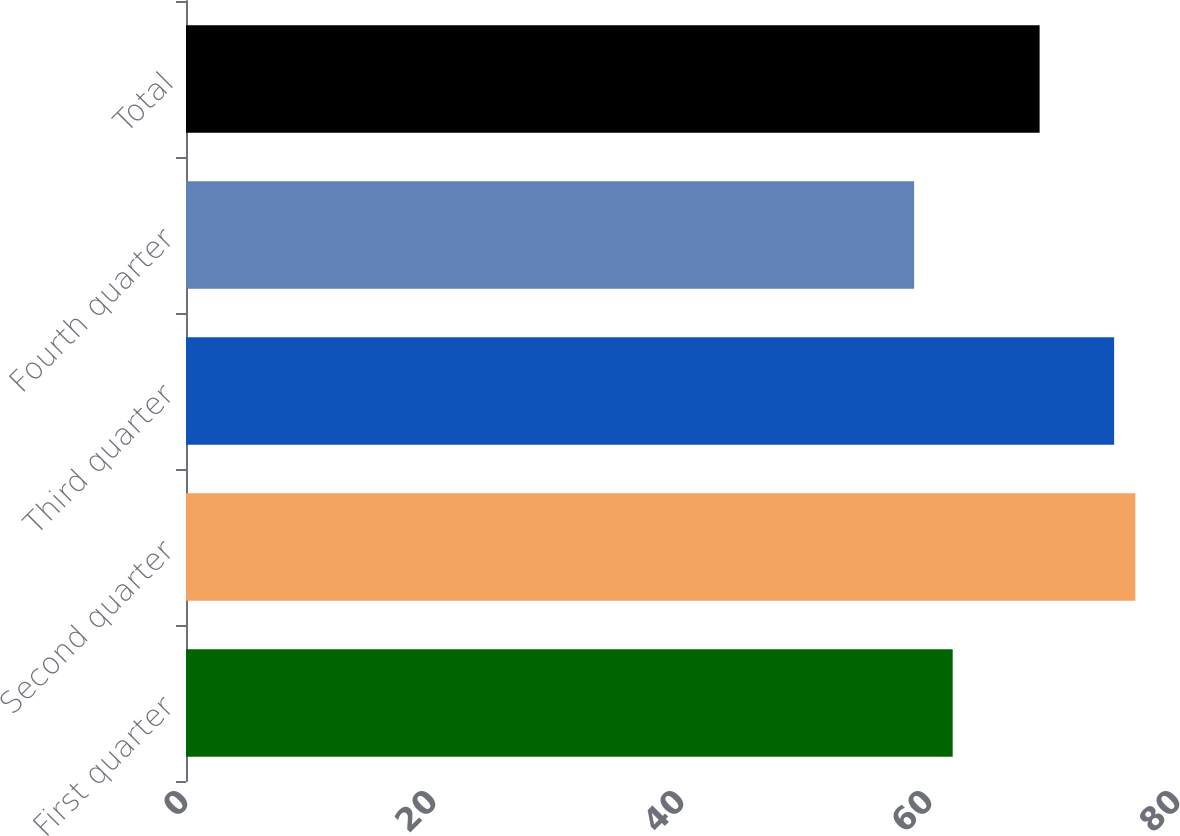<chart> <loc_0><loc_0><loc_500><loc_500><bar_chart><fcel>First quarter<fcel>Second quarter<fcel>Third quarter<fcel>Fourth quarter<fcel>Total<nl><fcel>61.83<fcel>76.56<fcel>74.85<fcel>58.72<fcel>68.84<nl></chart> 